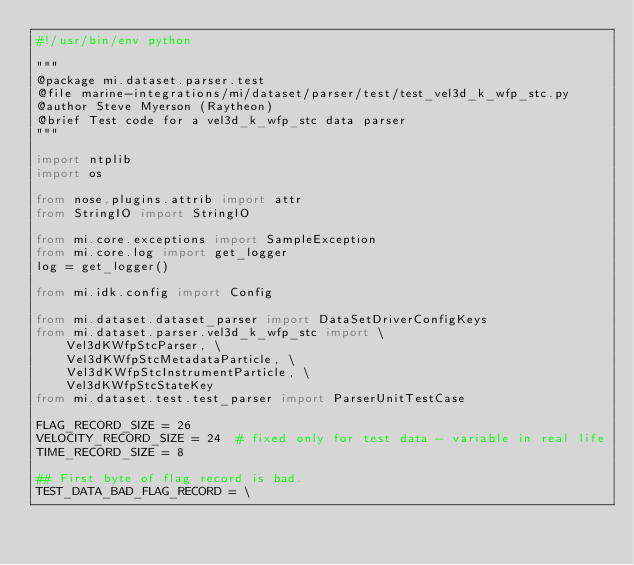Convert code to text. <code><loc_0><loc_0><loc_500><loc_500><_Python_>#!/usr/bin/env python

"""
@package mi.dataset.parser.test
@file marine-integrations/mi/dataset/parser/test/test_vel3d_k_wfp_stc.py
@author Steve Myerson (Raytheon)
@brief Test code for a vel3d_k_wfp_stc data parser
"""

import ntplib
import os

from nose.plugins.attrib import attr
from StringIO import StringIO

from mi.core.exceptions import SampleException
from mi.core.log import get_logger
log = get_logger()

from mi.idk.config import Config

from mi.dataset.dataset_parser import DataSetDriverConfigKeys
from mi.dataset.parser.vel3d_k_wfp_stc import \
    Vel3dKWfpStcParser, \
    Vel3dKWfpStcMetadataParticle, \
    Vel3dKWfpStcInstrumentParticle, \
    Vel3dKWfpStcStateKey
from mi.dataset.test.test_parser import ParserUnitTestCase

FLAG_RECORD_SIZE = 26 
VELOCITY_RECORD_SIZE = 24  # fixed only for test data - variable in real life
TIME_RECORD_SIZE = 8

## First byte of flag record is bad.
TEST_DATA_BAD_FLAG_RECORD = \</code> 